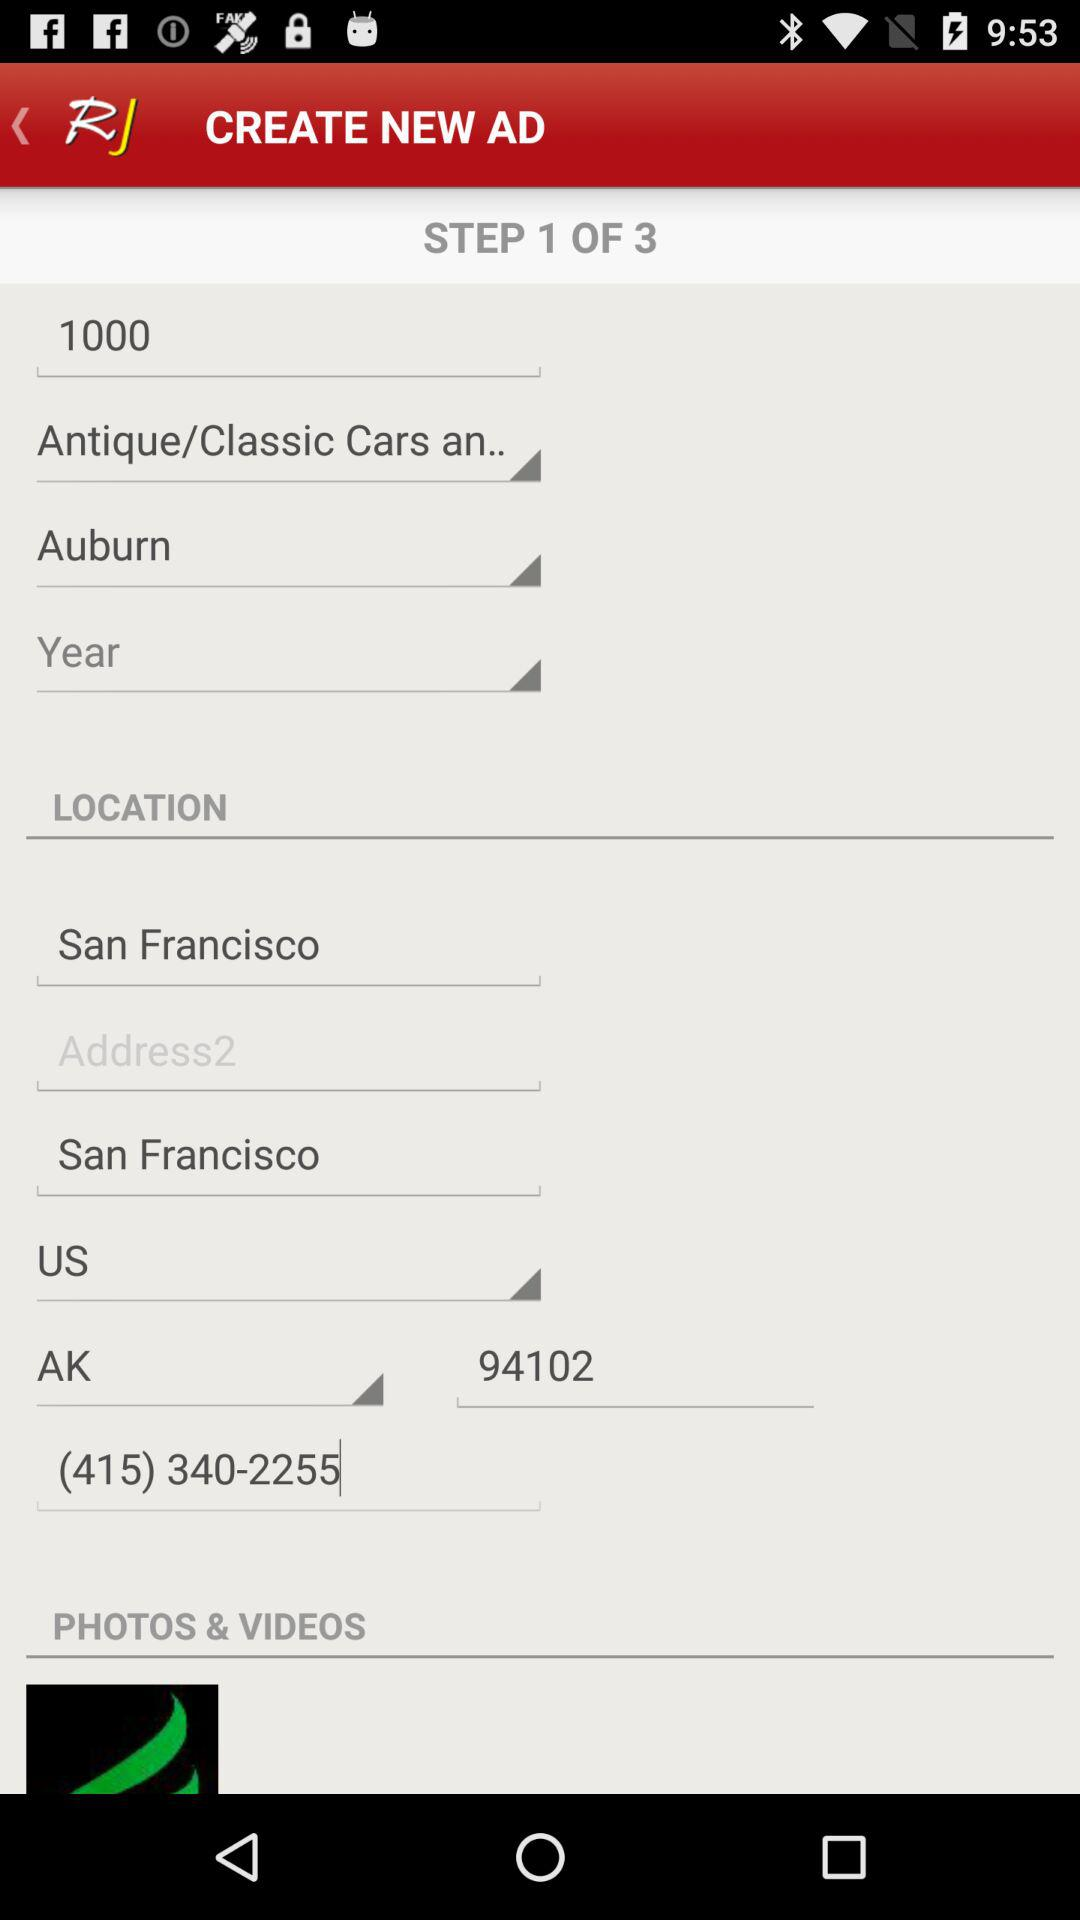Which country is selected in the ad form? The selected country is the US. 